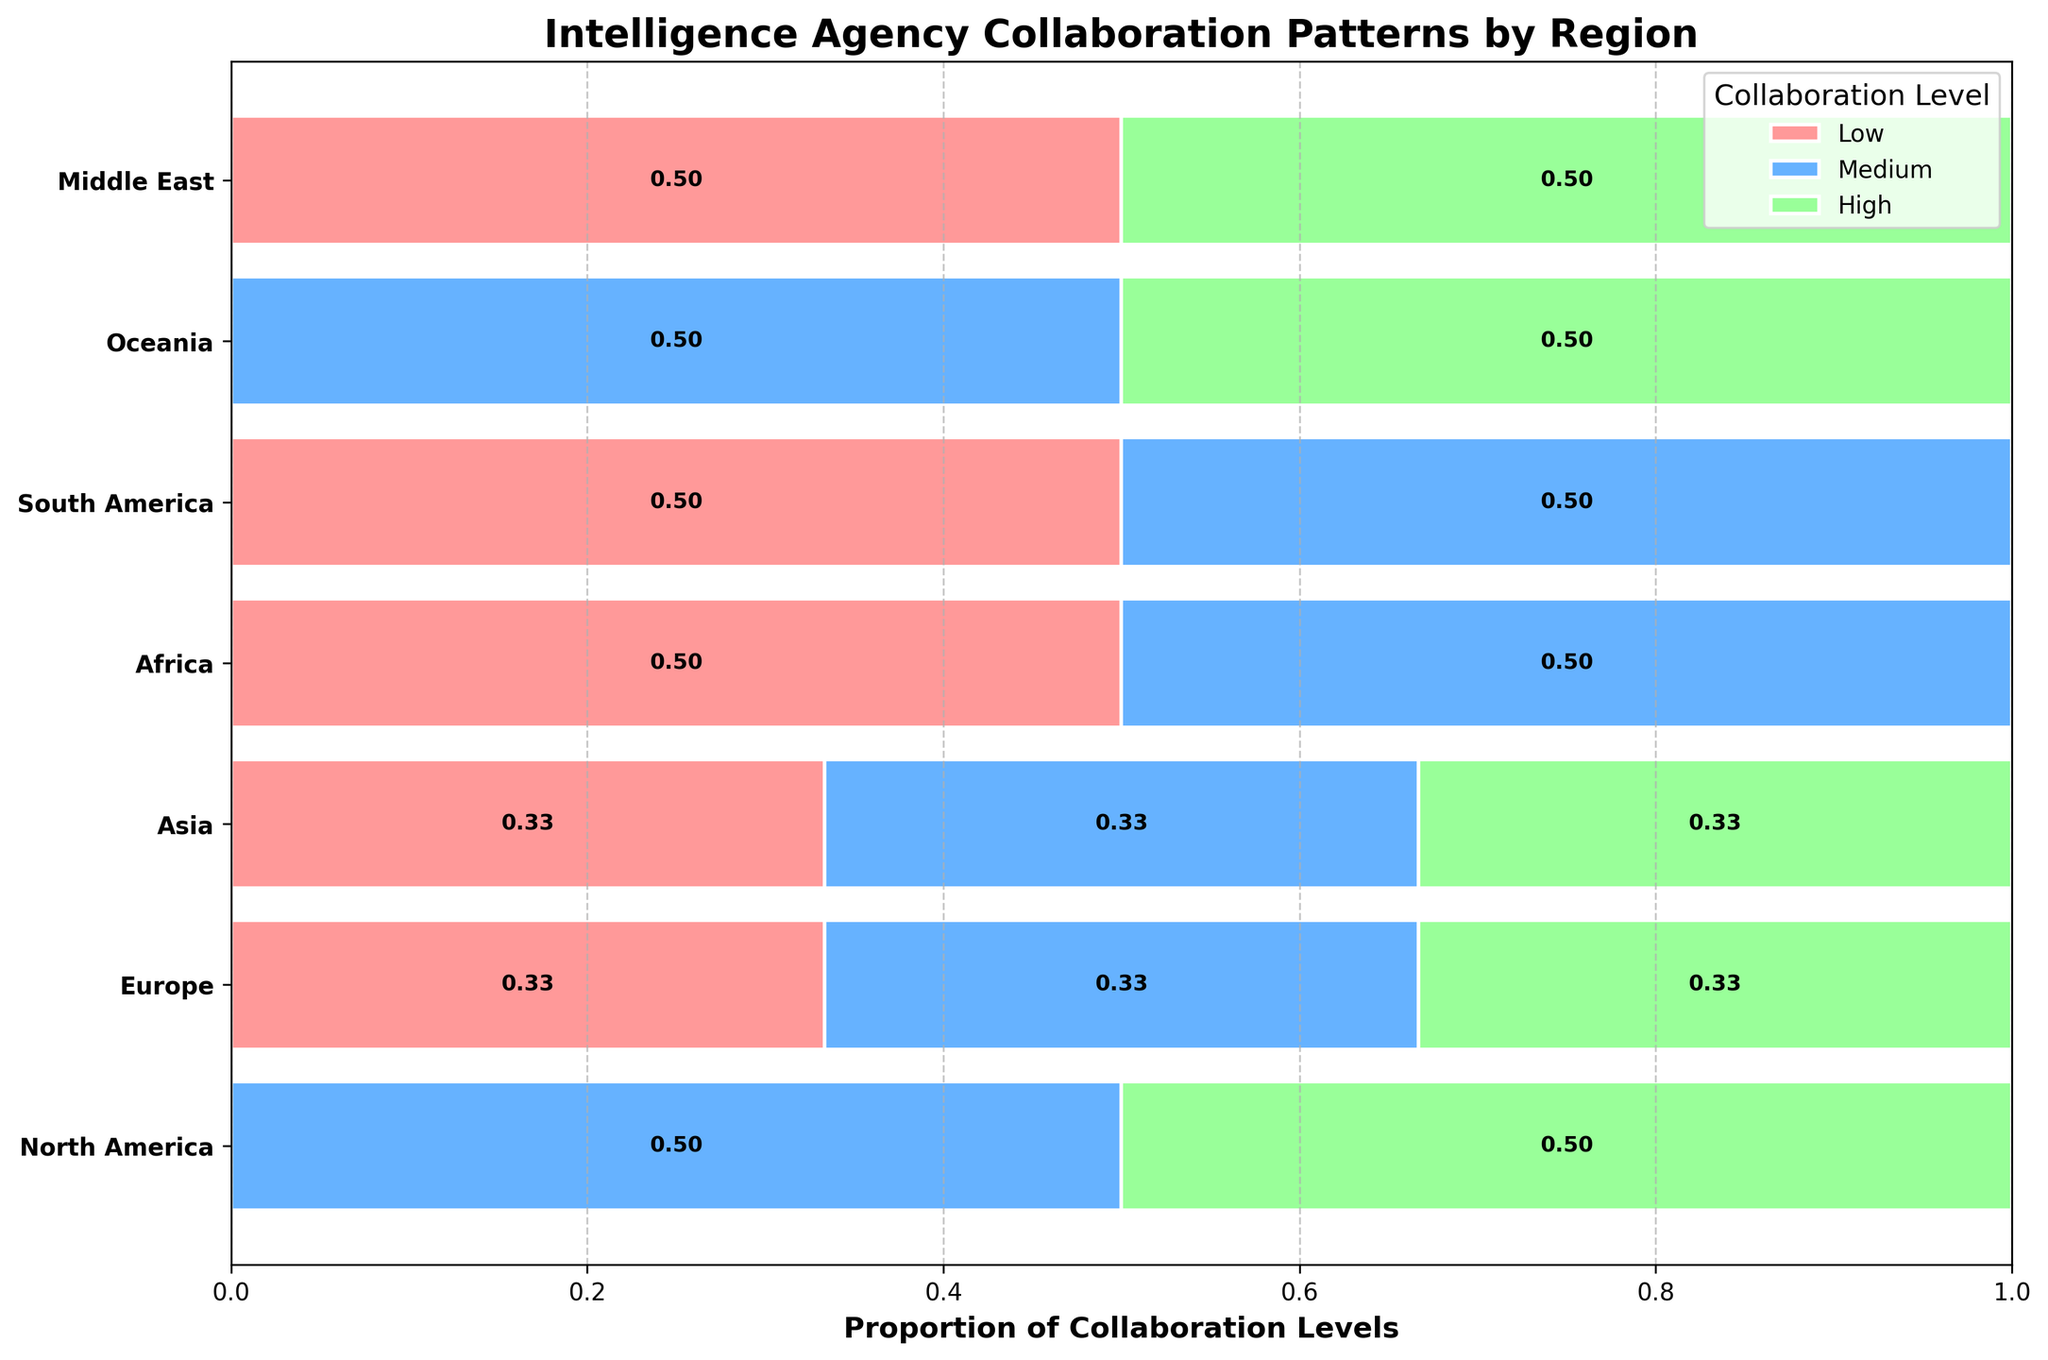What regions have intelligence agencies with a 'High' collaboration level? By referring to the plot, you can identify the regions where segments colored in green (High collaboration level) are present. These regions are North America, Europe, Asia, Oceania, and the Middle East.
Answer: North America, Europe, Asia, Oceania, Middle East How many regions have intelligence agencies with a 'Low' collaboration level? Count the number of regions that have segments colored in red (Low collaboration level). North America, Europe, Asia, Africa, South America, and the Middle East all have 'Low' collaboration levels shown, totaling six regions.
Answer: 6 Which region shows the highest proportion of 'Medium' collaboration levels among its intelligence agencies? Look for the widest segment colored in blue (Medium collaboration level). South America offers the highest proportion as it has notably wider blue segments compared to other regions.
Answer: South America Compare the proportion of 'High' collaboration levels between Europe and Oceania. Which region has a higher proportion? Examine the green segments for Europe and Oceania. Both regions have green segments, but to determine which is higher, compare the relative width proportionally. Europe has a wider green bar, indicating a higher proportion.
Answer: Europe For the region of Asia, what is the combined proportion of 'Low' and 'Medium' collaboration levels? Add the widths of the red and blue segments for Asia. Refer to the data labels if they exist. 'Low' collaboration level (red) covers about one-third and 'Medium' (blue) seems to cover another third, thus combined they constitute about 0.66 or 66% of Asia's collaboration levels.
Answer: 0.66 (66%) What is the total number of intelligence agencies displayed in the figure? Count all the individual agencies listed across all the regions: CIA, CSIS, MI6, DGSE, BND, Mossad, RAW, MSS, NIA, NISS, ABIN, SIDE, ASIS, NZSIS, GID, MOIS. There are 16 unique agencies.
Answer: 16 How does the collaboration pattern in Africa compare with that in North America? Look at the distribution of colors for Africa and North America. Africa has a dominant red segment ('Low' collaboration) and a smaller blue segment ('Medium' collaboration). North America has a larger green segment ('High' collaboration) and a moderately sized blue segment ('Medium' collaboration), indicating stronger collaborative efforts.
Answer: Africa has lower collaboration levels compared to North America Which collaboration level is not found in South America? Check the segments representing South America. It's clear no green segment ('High' collaboration level) appears, only red and blue segments are present.
Answer: High Is the proportion of 'High' collaboration in North America equal to that in Europe? Compare the widths of the green segments in North America and Europe. Both green segments cover roughly the same wide proportion.
Answer: Yes What is the least common collaboration level in the Middle East? Observe the widths of segments for the Middle East. The red ('Low') and green ('High') segments are both present, but the red segment is thinner. The blue segment ('Medium') is absent. Thus, the least common is 'Medium'.
Answer: Medium 